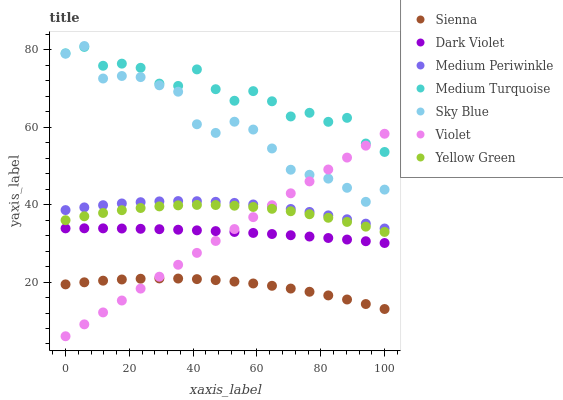Does Sienna have the minimum area under the curve?
Answer yes or no. Yes. Does Medium Turquoise have the maximum area under the curve?
Answer yes or no. Yes. Does Medium Periwinkle have the minimum area under the curve?
Answer yes or no. No. Does Medium Periwinkle have the maximum area under the curve?
Answer yes or no. No. Is Violet the smoothest?
Answer yes or no. Yes. Is Medium Turquoise the roughest?
Answer yes or no. Yes. Is Medium Periwinkle the smoothest?
Answer yes or no. No. Is Medium Periwinkle the roughest?
Answer yes or no. No. Does Violet have the lowest value?
Answer yes or no. Yes. Does Medium Periwinkle have the lowest value?
Answer yes or no. No. Does Sky Blue have the highest value?
Answer yes or no. Yes. Does Medium Periwinkle have the highest value?
Answer yes or no. No. Is Sienna less than Medium Periwinkle?
Answer yes or no. Yes. Is Yellow Green greater than Dark Violet?
Answer yes or no. Yes. Does Medium Turquoise intersect Violet?
Answer yes or no. Yes. Is Medium Turquoise less than Violet?
Answer yes or no. No. Is Medium Turquoise greater than Violet?
Answer yes or no. No. Does Sienna intersect Medium Periwinkle?
Answer yes or no. No. 